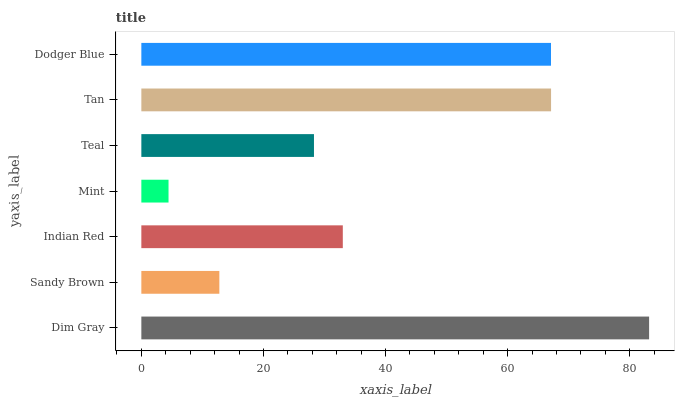Is Mint the minimum?
Answer yes or no. Yes. Is Dim Gray the maximum?
Answer yes or no. Yes. Is Sandy Brown the minimum?
Answer yes or no. No. Is Sandy Brown the maximum?
Answer yes or no. No. Is Dim Gray greater than Sandy Brown?
Answer yes or no. Yes. Is Sandy Brown less than Dim Gray?
Answer yes or no. Yes. Is Sandy Brown greater than Dim Gray?
Answer yes or no. No. Is Dim Gray less than Sandy Brown?
Answer yes or no. No. Is Indian Red the high median?
Answer yes or no. Yes. Is Indian Red the low median?
Answer yes or no. Yes. Is Dodger Blue the high median?
Answer yes or no. No. Is Tan the low median?
Answer yes or no. No. 